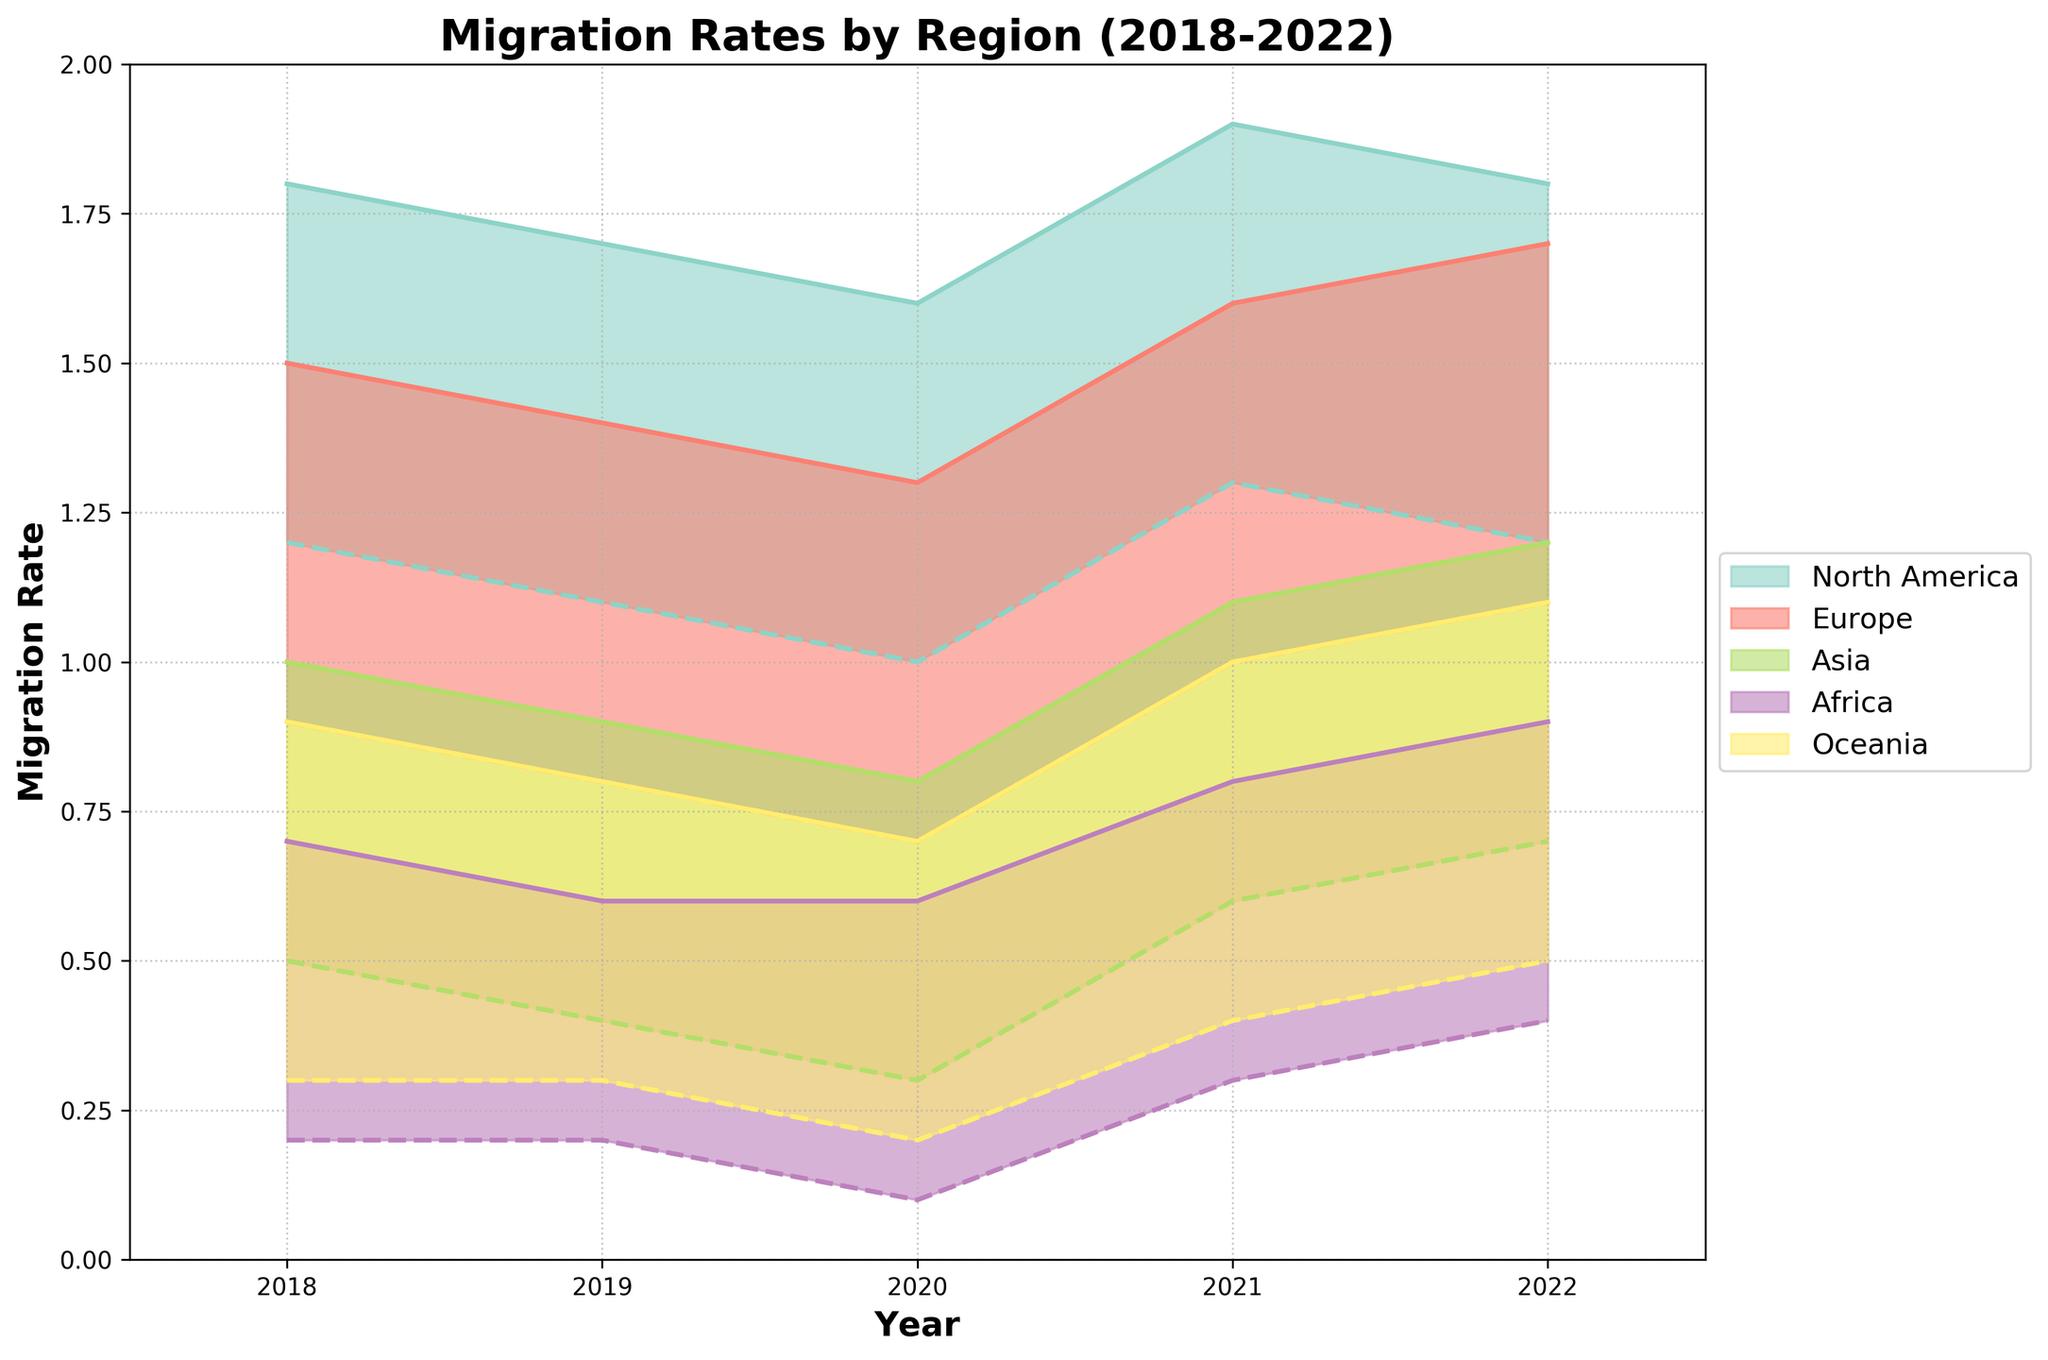What is the title of the chart? The title of the chart is displayed prominently at the top of the figure in bold font.
Answer: Migration Rates by Region (2018-2022) What does the x-axis represent? The x-axis is labeled 'Year' and displays a range of years from 2018 to 2022.
Answer: Year Which region has the highest migration rate in 2022? By looking at the maximum migration rates for 2022, North America has the highest rate as indicated by the top of the filled area.
Answer: North America What is the approximate migration rate range for Europe in 2020? The min and max lines for Europe in 2020 show the migration rates. The range is from 0.7 to 1.3.
Answer: 0.7 to 1.3 Which region shows the most variability in migration rate over the years? The width of the range (min to max) for each year indicates variability. North America has the widest range over multiple years, showing the most variability.
Answer: North America In which year did Oceania experience the lowest minimum migration rate? The lowest minimum migration rate for Oceania is indicated by the lowest point of the dashed line in 2020.
Answer: 2020 What is the trend of the minimum migration rate for Asia from 2018 to 2022? The minimum migration rate for Asia decreases from 0.5 in 2018 to 0.3 in 2020 and then increases to 0.7 in 2022, reversing the initial decline.
Answer: Decrease then increase How does Africa's maximum migration rate in 2022 compare to its rate in 2018? Africa's maximum migration rate increases from 0.7 in 2018 to 0.9 in 2022, which can be seen by comparing the top lines for these years.
Answer: Increased Between which years did Europe see the most significant rise in its minimum migration rate? The minimum migration rate for Europe saw a rise from 0.7 in 2020 to 1.0 in 2021, indicating the most significant change.
Answer: 2020 to 2021 Which region has the least variation in migration rates throughout the years? By observing the narrower width of the filled area, Asia shows the least variation in migration rates across the years.
Answer: Asia 